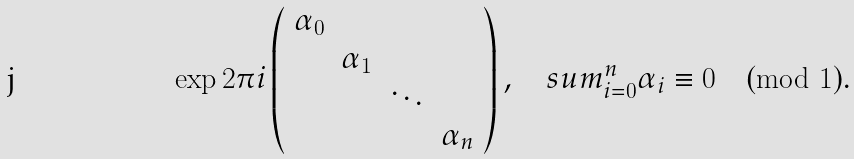Convert formula to latex. <formula><loc_0><loc_0><loc_500><loc_500>\exp 2 \pi i \left ( \begin{array} { c c c c } \alpha _ { 0 } & & & \\ & \alpha _ { 1 } & & \\ & & \ddots & \\ & & & \alpha _ { n } \end{array} \right ) , \quad s u m ^ { n } _ { i = 0 } \alpha _ { i } \equiv 0 \pmod { 1 } .</formula> 